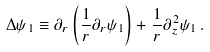<formula> <loc_0><loc_0><loc_500><loc_500>\Delta \psi _ { 1 } \equiv \partial _ { r } \left ( \frac { 1 } { r } \partial _ { r } \psi _ { 1 } \right ) + \frac { 1 } { r } \partial ^ { 2 } _ { z } \psi _ { 1 } \, .</formula> 